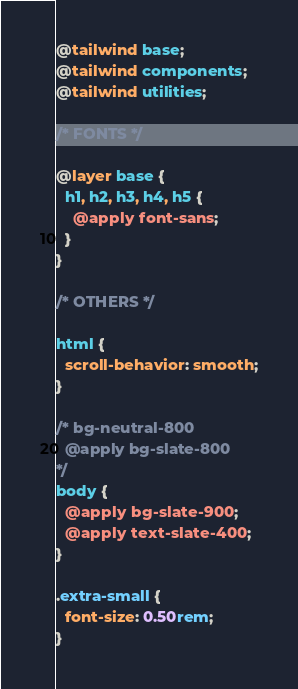<code> <loc_0><loc_0><loc_500><loc_500><_CSS_>@tailwind base;
@tailwind components;
@tailwind utilities;

/* FONTS */

@layer base {
  h1, h2, h3, h4, h5 {
    @apply font-sans;
  }
}

/* OTHERS */

html {
  scroll-behavior: smooth;
}

/* bg-neutral-800
  @apply bg-slate-800
*/
body {
  @apply bg-slate-900;
  @apply text-slate-400;
}

.extra-small {
  font-size: 0.50rem;
}
</code> 